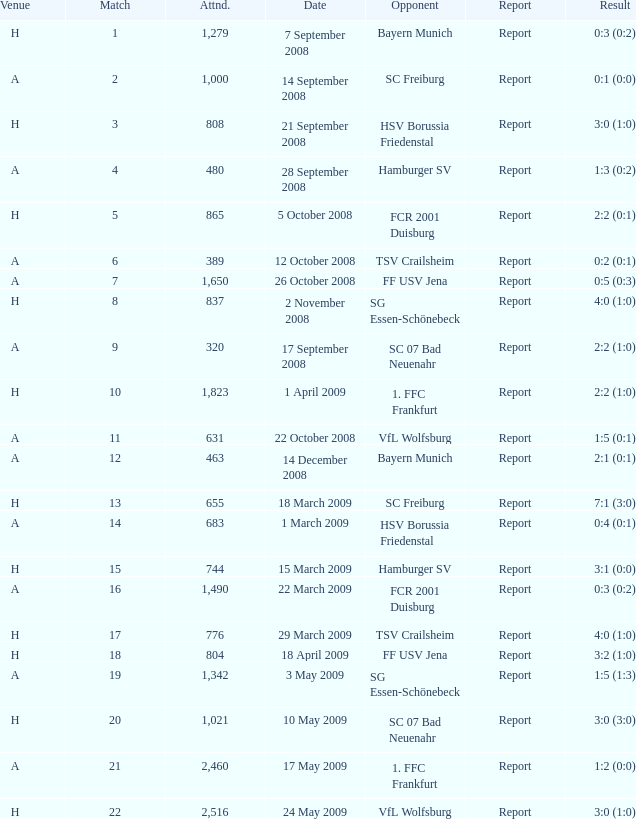Help me parse the entirety of this table. {'header': ['Venue', 'Match', 'Attnd.', 'Date', 'Opponent', 'Report', 'Result'], 'rows': [['H', '1', '1,279', '7 September 2008', 'Bayern Munich', 'Report', '0:3 (0:2)'], ['A', '2', '1,000', '14 September 2008', 'SC Freiburg', 'Report', '0:1 (0:0)'], ['H', '3', '808', '21 September 2008', 'HSV Borussia Friedenstal', 'Report', '3:0 (1:0)'], ['A', '4', '480', '28 September 2008', 'Hamburger SV', 'Report', '1:3 (0:2)'], ['H', '5', '865', '5 October 2008', 'FCR 2001 Duisburg', 'Report', '2:2 (0:1)'], ['A', '6', '389', '12 October 2008', 'TSV Crailsheim', 'Report', '0:2 (0:1)'], ['A', '7', '1,650', '26 October 2008', 'FF USV Jena', 'Report', '0:5 (0:3)'], ['H', '8', '837', '2 November 2008', 'SG Essen-Schönebeck', 'Report', '4:0 (1:0)'], ['A', '9', '320', '17 September 2008', 'SC 07 Bad Neuenahr', 'Report', '2:2 (1:0)'], ['H', '10', '1,823', '1 April 2009', '1. FFC Frankfurt', 'Report', '2:2 (1:0)'], ['A', '11', '631', '22 October 2008', 'VfL Wolfsburg', 'Report', '1:5 (0:1)'], ['A', '12', '463', '14 December 2008', 'Bayern Munich', 'Report', '2:1 (0:1)'], ['H', '13', '655', '18 March 2009', 'SC Freiburg', 'Report', '7:1 (3:0)'], ['A', '14', '683', '1 March 2009', 'HSV Borussia Friedenstal', 'Report', '0:4 (0:1)'], ['H', '15', '744', '15 March 2009', 'Hamburger SV', 'Report', '3:1 (0:0)'], ['A', '16', '1,490', '22 March 2009', 'FCR 2001 Duisburg', 'Report', '0:3 (0:2)'], ['H', '17', '776', '29 March 2009', 'TSV Crailsheim', 'Report', '4:0 (1:0)'], ['H', '18', '804', '18 April 2009', 'FF USV Jena', 'Report', '3:2 (1:0)'], ['A', '19', '1,342', '3 May 2009', 'SG Essen-Schönebeck', 'Report', '1:5 (1:3)'], ['H', '20', '1,021', '10 May 2009', 'SC 07 Bad Neuenahr', 'Report', '3:0 (3:0)'], ['A', '21', '2,460', '17 May 2009', '1. FFC Frankfurt', 'Report', '1:2 (0:0)'], ['H', '22', '2,516', '24 May 2009', 'VfL Wolfsburg', 'Report', '3:0 (1:0)']]} Which match did FCR 2001 Duisburg participate as the opponent? 21.0. 